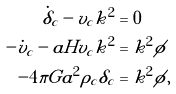Convert formula to latex. <formula><loc_0><loc_0><loc_500><loc_500>\dot { \delta } _ { c } - v _ { c } k ^ { 2 } & = 0 \\ - \dot { v } _ { c } - a H v _ { c } k ^ { 2 } & = k ^ { 2 } \phi \\ - 4 \pi G a ^ { 2 } \rho _ { c } \delta _ { c } & = k ^ { 2 } \phi ,</formula> 